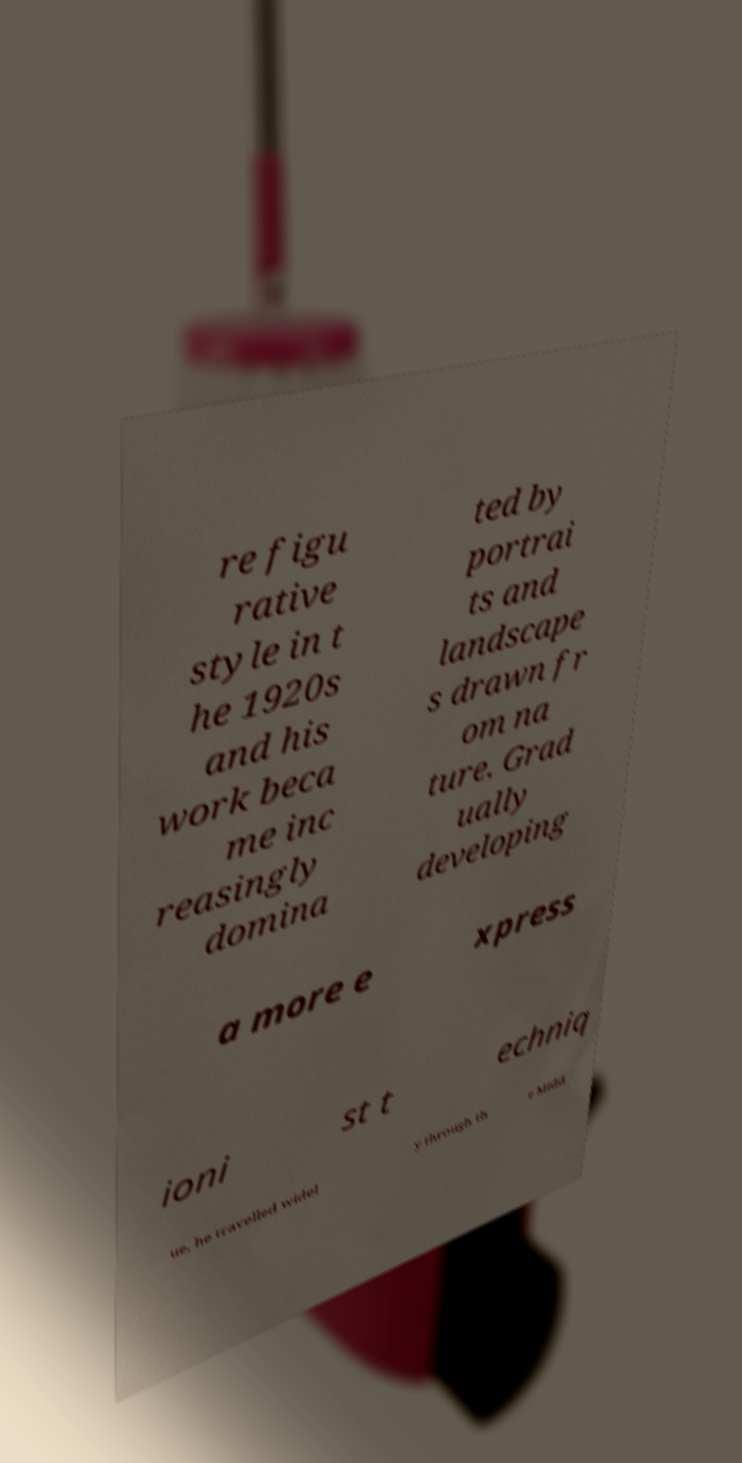Please identify and transcribe the text found in this image. re figu rative style in t he 1920s and his work beca me inc reasingly domina ted by portrai ts and landscape s drawn fr om na ture. Grad ually developing a more e xpress ioni st t echniq ue, he travelled widel y through th e Midd 